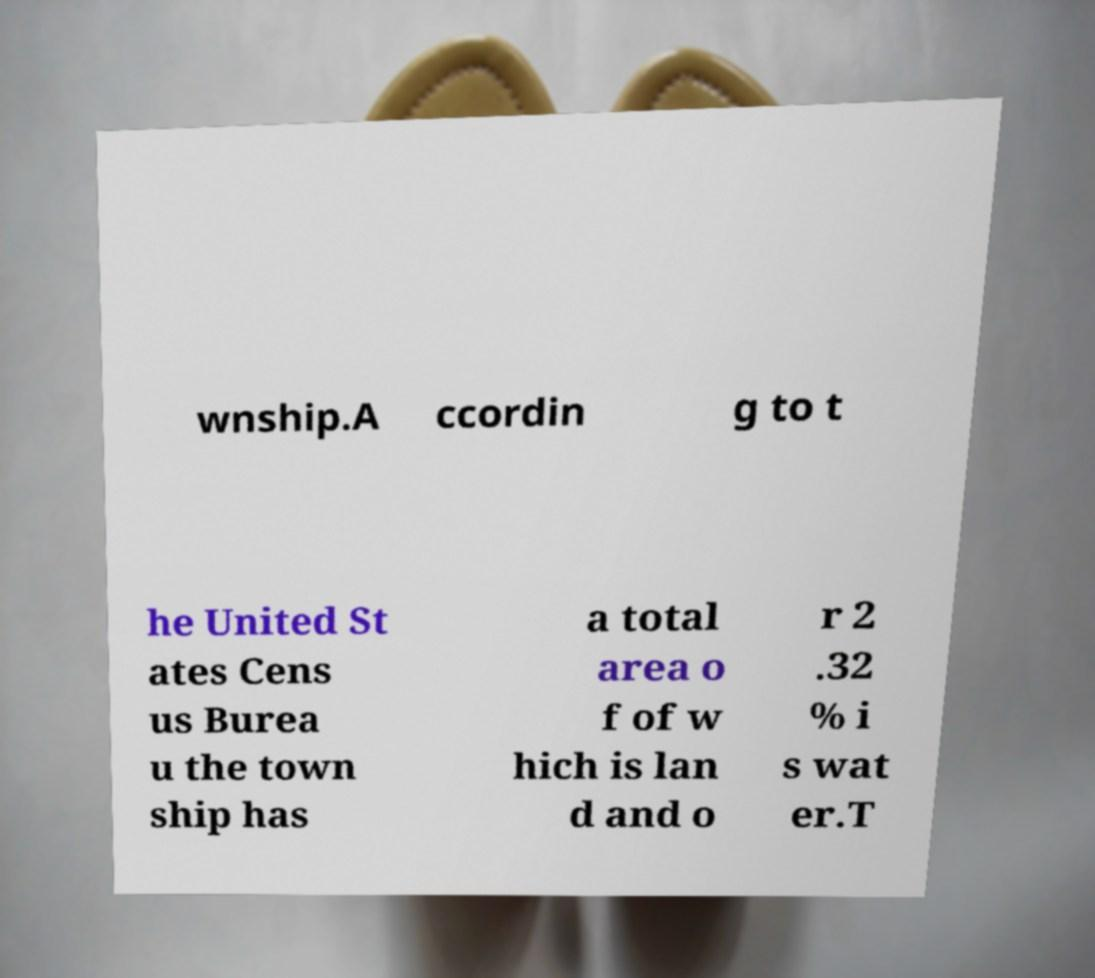I need the written content from this picture converted into text. Can you do that? wnship.A ccordin g to t he United St ates Cens us Burea u the town ship has a total area o f of w hich is lan d and o r 2 .32 % i s wat er.T 